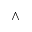<formula> <loc_0><loc_0><loc_500><loc_500>\wedge</formula> 